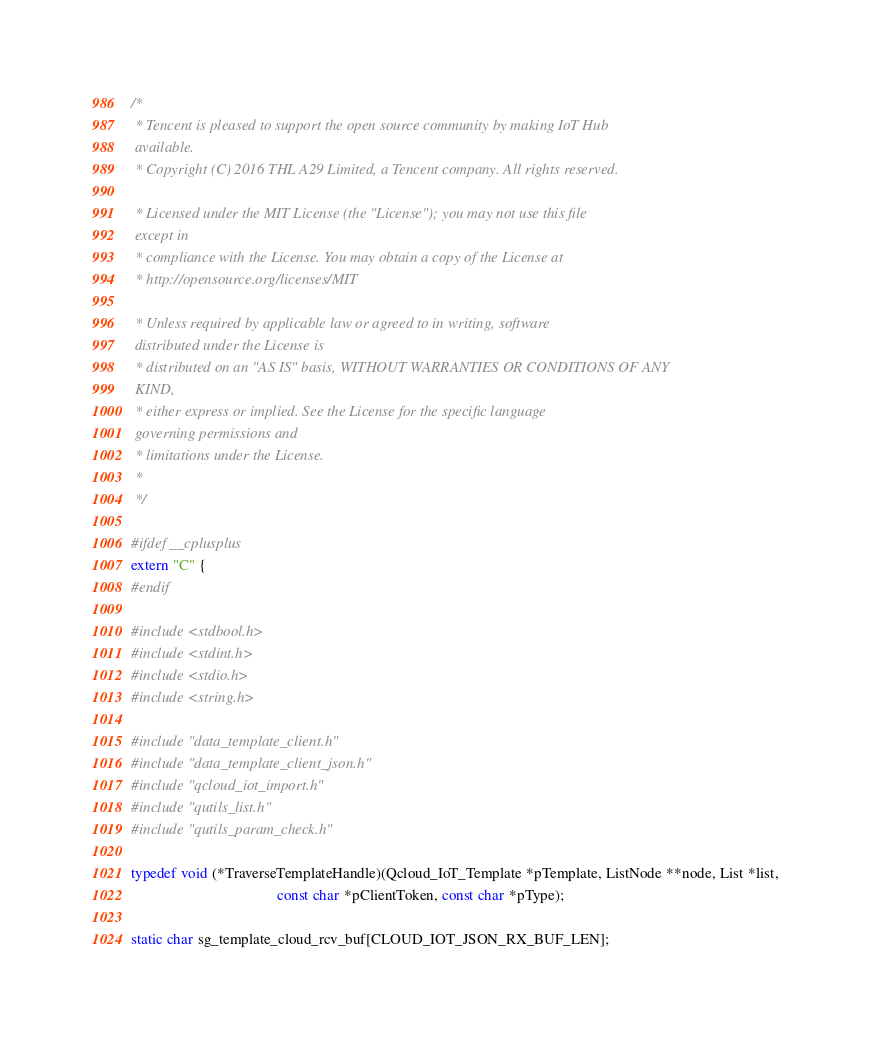Convert code to text. <code><loc_0><loc_0><loc_500><loc_500><_C_>/*
 * Tencent is pleased to support the open source community by making IoT Hub
 available.
 * Copyright (C) 2016 THL A29 Limited, a Tencent company. All rights reserved.

 * Licensed under the MIT License (the "License"); you may not use this file
 except in
 * compliance with the License. You may obtain a copy of the License at
 * http://opensource.org/licenses/MIT

 * Unless required by applicable law or agreed to in writing, software
 distributed under the License is
 * distributed on an "AS IS" basis, WITHOUT WARRANTIES OR CONDITIONS OF ANY
 KIND,
 * either express or implied. See the License for the specific language
 governing permissions and
 * limitations under the License.
 *
 */

#ifdef __cplusplus
extern "C" {
#endif

#include <stdbool.h>
#include <stdint.h>
#include <stdio.h>
#include <string.h>

#include "data_template_client.h"
#include "data_template_client_json.h"
#include "qcloud_iot_import.h"
#include "qutils_list.h"
#include "qutils_param_check.h"

typedef void (*TraverseTemplateHandle)(Qcloud_IoT_Template *pTemplate, ListNode **node, List *list,
                                       const char *pClientToken, const char *pType);

static char sg_template_cloud_rcv_buf[CLOUD_IOT_JSON_RX_BUF_LEN];</code> 